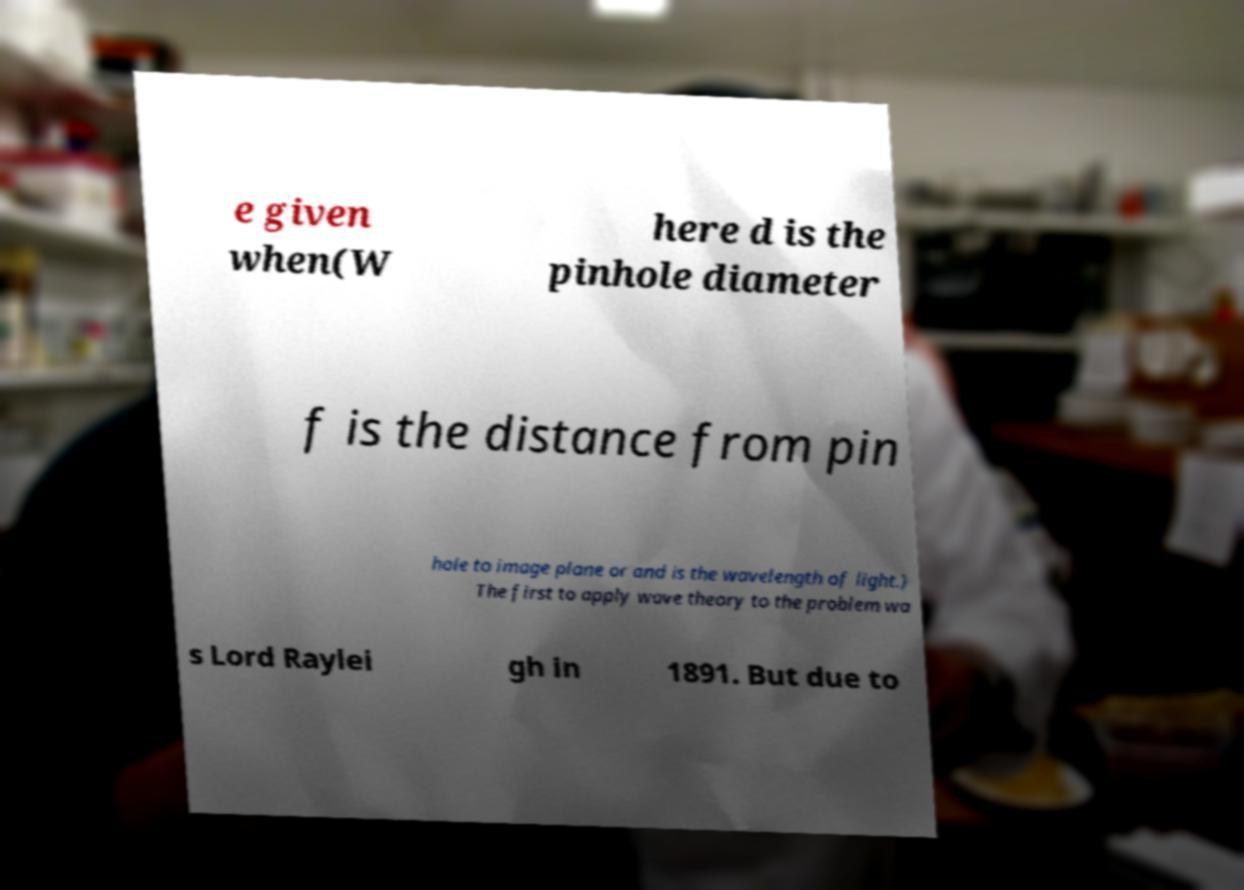I need the written content from this picture converted into text. Can you do that? e given when(W here d is the pinhole diameter f is the distance from pin hole to image plane or and is the wavelength of light.) The first to apply wave theory to the problem wa s Lord Raylei gh in 1891. But due to 